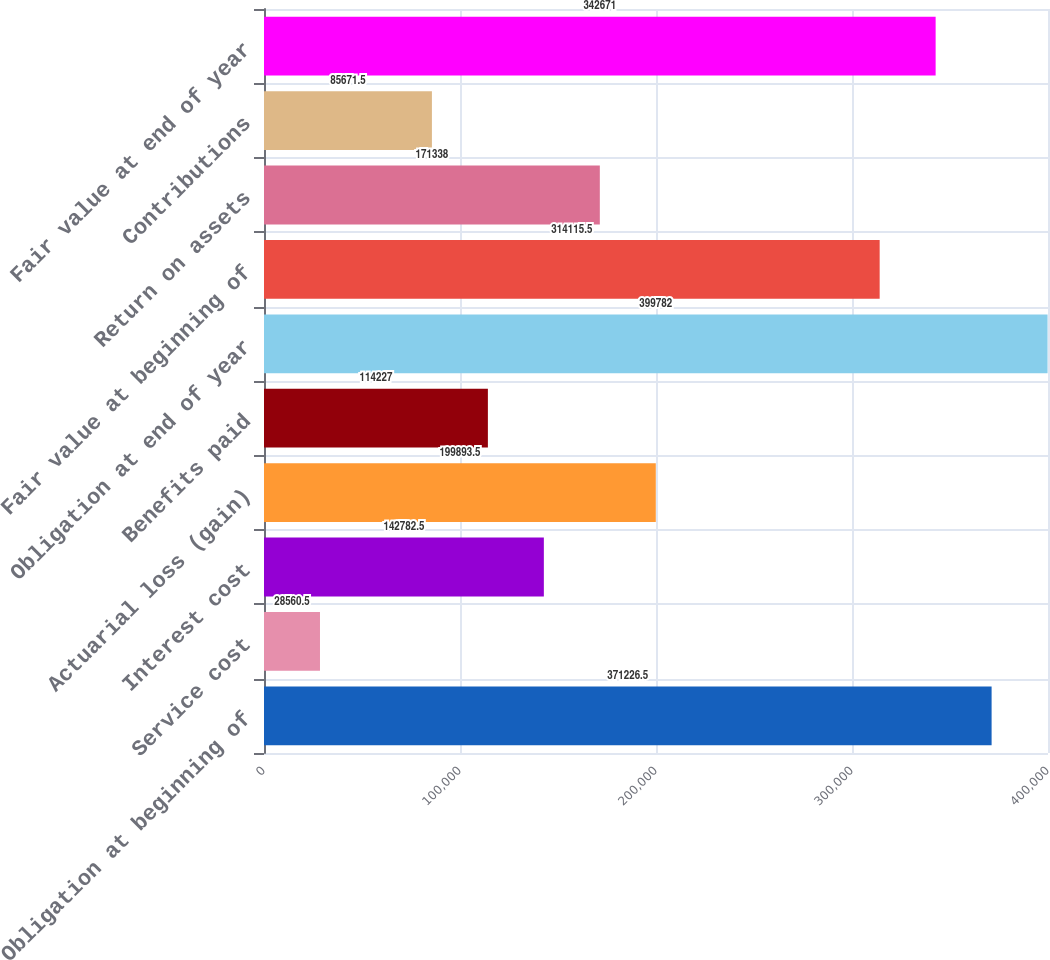Convert chart. <chart><loc_0><loc_0><loc_500><loc_500><bar_chart><fcel>Obligation at beginning of<fcel>Service cost<fcel>Interest cost<fcel>Actuarial loss (gain)<fcel>Benefits paid<fcel>Obligation at end of year<fcel>Fair value at beginning of<fcel>Return on assets<fcel>Contributions<fcel>Fair value at end of year<nl><fcel>371226<fcel>28560.5<fcel>142782<fcel>199894<fcel>114227<fcel>399782<fcel>314116<fcel>171338<fcel>85671.5<fcel>342671<nl></chart> 